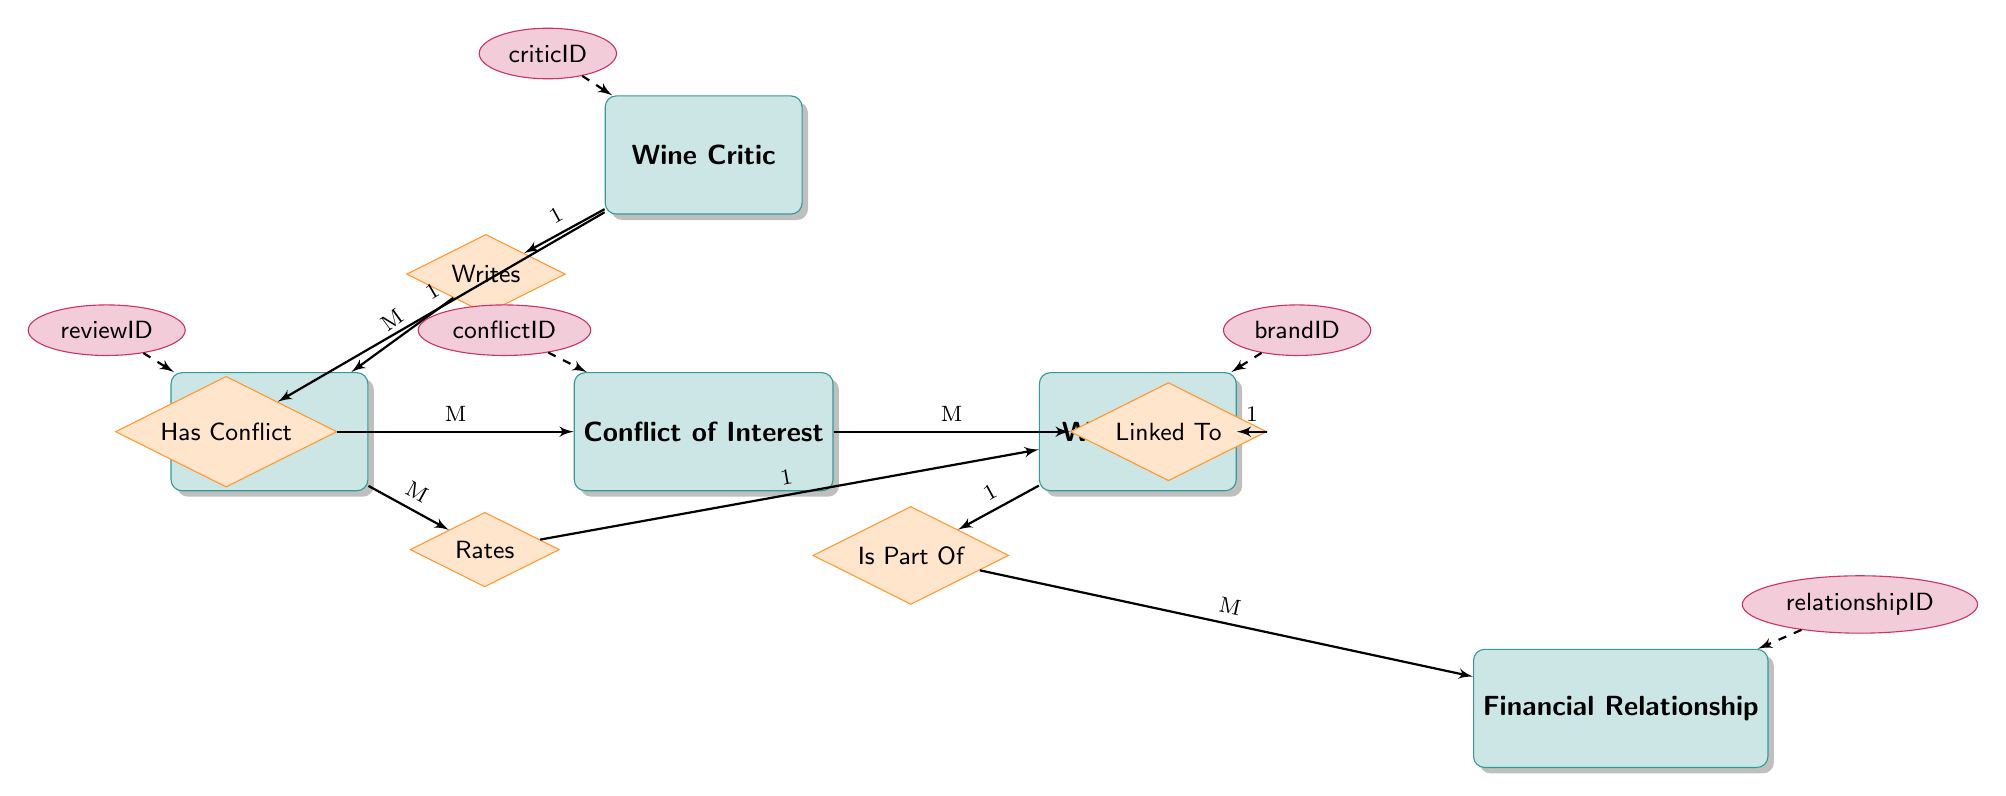What is the primary key of the WineCritic entity? The primary key of the WineCritic entity is criticID, as indicated in the attributes listed for that entity.
Answer: criticID How many entities are in the diagram? The diagram lists five entities: WineCritic, WineBrand, Review, ConflictOfInterest, and FinancialRelationship. By counting them, we find that there are five entities in total.
Answer: 5 What type of relationship exists between WineCritic and Review? The relationship between WineCritic and Review is labeled "Writes," and its cardinality is 1 to many (1:M), indicating that one WineCritic can write multiple Reviews.
Answer: Writes Which entity has a relationship of "Is Part Of"? The relationship "Is Part Of" connects the WineBrand to FinancialRelationship, indicating that each WineBrand can be part of multiple FinancialRelationships.
Answer: WineBrand What is the cardinality between Review and WineBrand? The cardinality between Review and WineBrand is many to one (M:1), meaning that multiple Reviews can be associated with a single WineBrand.
Answer: M:1 Identify the primary key of the ConflictOfInterest entity. The primary key of the ConflictOfInterest entity is conflictID, as shown in the list of attributes for that entity.
Answer: conflictID How many conflicts can a WineCritic have? The relationship "Has Conflict" shows that one WineCritic can have multiple conflicts (1:M), implying that there is no limit to how many conflicts they can have; however, the relationship is specifically one to many.
Answer: Many What is the relationship type linking ConflictOfInterest and WineBrand? The relationship type linking ConflictOfInterest and WineBrand is labeled "Linked To," with a cardinality of many to one (M:1), which implies that multiple conflicts can relate to a single WineBrand.
Answer: Linked To In the context of the diagram, why might a WineCritic have a ConflictOfInterest? The diagram indicates that if a WineCritic has a financial relationship with a WineBrand, it may create a ConflictOfInterest. This suggests that financial ties could bias the critic's reviews.
Answer: Financial Relationship 